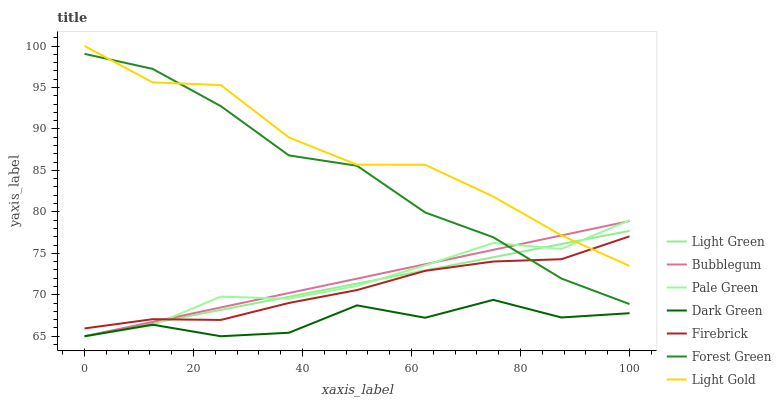Does Dark Green have the minimum area under the curve?
Answer yes or no. Yes. Does Light Gold have the maximum area under the curve?
Answer yes or no. Yes. Does Bubblegum have the minimum area under the curve?
Answer yes or no. No. Does Bubblegum have the maximum area under the curve?
Answer yes or no. No. Is Bubblegum the smoothest?
Answer yes or no. Yes. Is Dark Green the roughest?
Answer yes or no. Yes. Is Forest Green the smoothest?
Answer yes or no. No. Is Forest Green the roughest?
Answer yes or no. No. Does Bubblegum have the lowest value?
Answer yes or no. Yes. Does Forest Green have the lowest value?
Answer yes or no. No. Does Light Gold have the highest value?
Answer yes or no. Yes. Does Bubblegum have the highest value?
Answer yes or no. No. Is Dark Green less than Light Gold?
Answer yes or no. Yes. Is Firebrick greater than Dark Green?
Answer yes or no. Yes. Does Pale Green intersect Dark Green?
Answer yes or no. Yes. Is Pale Green less than Dark Green?
Answer yes or no. No. Is Pale Green greater than Dark Green?
Answer yes or no. No. Does Dark Green intersect Light Gold?
Answer yes or no. No. 